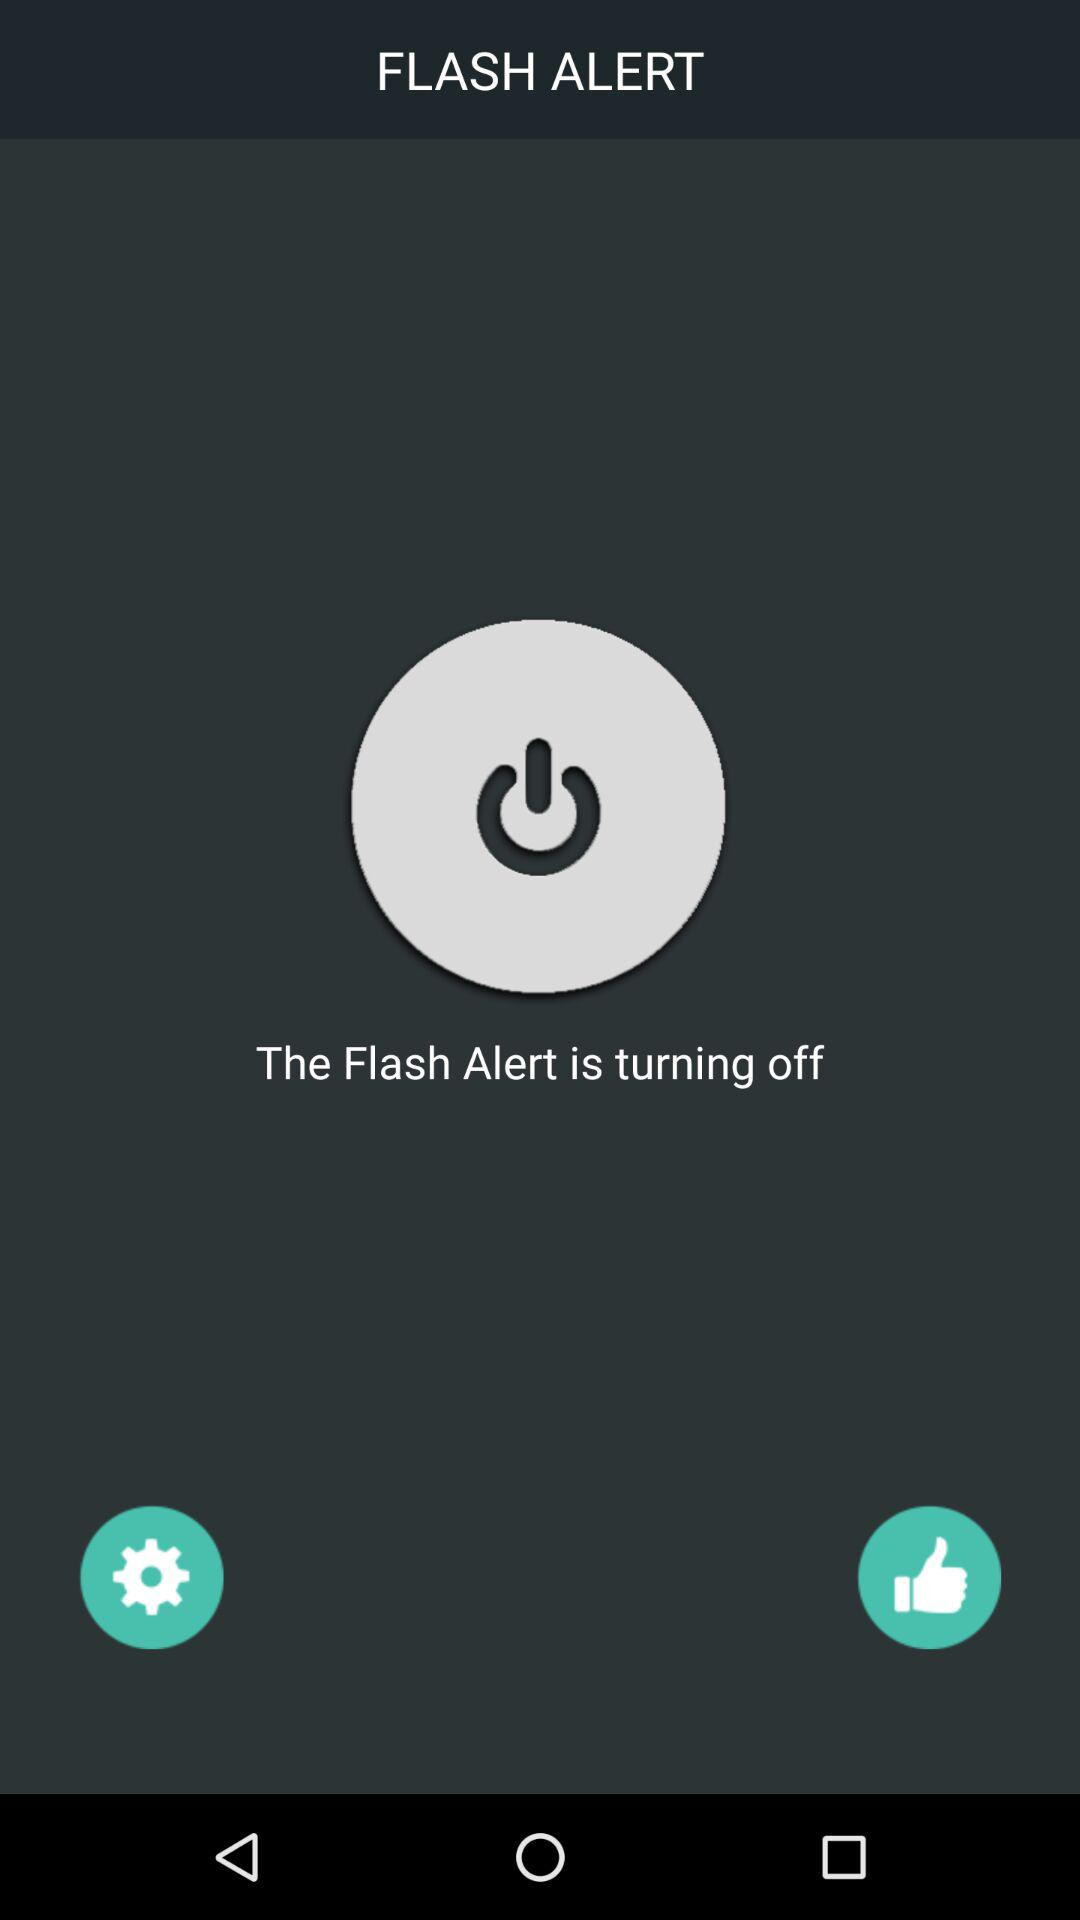What is the status of the flash alert? The status is "off". 